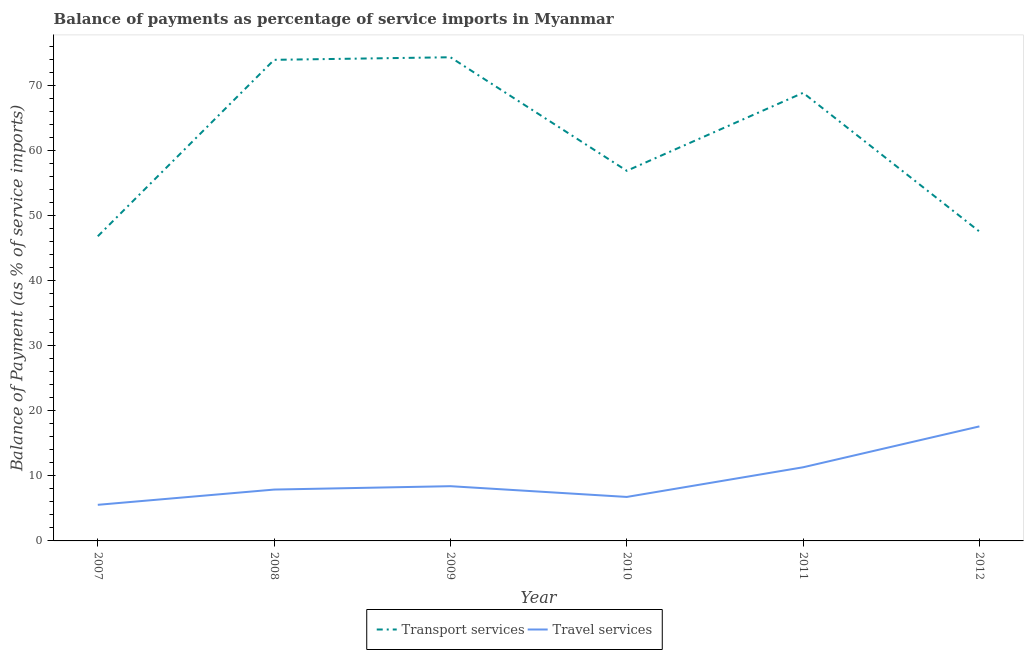How many different coloured lines are there?
Your answer should be compact. 2. Does the line corresponding to balance of payments of travel services intersect with the line corresponding to balance of payments of transport services?
Offer a very short reply. No. Is the number of lines equal to the number of legend labels?
Your response must be concise. Yes. What is the balance of payments of travel services in 2010?
Keep it short and to the point. 6.76. Across all years, what is the maximum balance of payments of travel services?
Offer a very short reply. 17.6. Across all years, what is the minimum balance of payments of travel services?
Your answer should be very brief. 5.55. What is the total balance of payments of transport services in the graph?
Give a very brief answer. 368.35. What is the difference between the balance of payments of transport services in 2009 and that in 2011?
Provide a succinct answer. 5.47. What is the difference between the balance of payments of transport services in 2012 and the balance of payments of travel services in 2009?
Give a very brief answer. 39.13. What is the average balance of payments of transport services per year?
Make the answer very short. 61.39. In the year 2009, what is the difference between the balance of payments of transport services and balance of payments of travel services?
Your answer should be very brief. 65.92. In how many years, is the balance of payments of transport services greater than 68 %?
Your answer should be very brief. 3. What is the ratio of the balance of payments of travel services in 2007 to that in 2011?
Your answer should be compact. 0.49. Is the difference between the balance of payments of transport services in 2007 and 2009 greater than the difference between the balance of payments of travel services in 2007 and 2009?
Offer a terse response. No. What is the difference between the highest and the second highest balance of payments of transport services?
Offer a terse response. 0.4. What is the difference between the highest and the lowest balance of payments of travel services?
Ensure brevity in your answer.  12.05. In how many years, is the balance of payments of travel services greater than the average balance of payments of travel services taken over all years?
Your response must be concise. 2. Is the sum of the balance of payments of transport services in 2007 and 2009 greater than the maximum balance of payments of travel services across all years?
Provide a succinct answer. Yes. Does the balance of payments of travel services monotonically increase over the years?
Offer a very short reply. No. Is the balance of payments of transport services strictly greater than the balance of payments of travel services over the years?
Keep it short and to the point. Yes. Is the balance of payments of transport services strictly less than the balance of payments of travel services over the years?
Ensure brevity in your answer.  No. How many lines are there?
Offer a very short reply. 2. Does the graph contain any zero values?
Your answer should be compact. No. Does the graph contain grids?
Make the answer very short. No. How many legend labels are there?
Your answer should be very brief. 2. What is the title of the graph?
Provide a short and direct response. Balance of payments as percentage of service imports in Myanmar. What is the label or title of the X-axis?
Make the answer very short. Year. What is the label or title of the Y-axis?
Your response must be concise. Balance of Payment (as % of service imports). What is the Balance of Payment (as % of service imports) in Transport services in 2007?
Ensure brevity in your answer.  46.82. What is the Balance of Payment (as % of service imports) of Travel services in 2007?
Your response must be concise. 5.55. What is the Balance of Payment (as % of service imports) of Transport services in 2008?
Your answer should be compact. 73.93. What is the Balance of Payment (as % of service imports) in Travel services in 2008?
Your answer should be compact. 7.89. What is the Balance of Payment (as % of service imports) in Transport services in 2009?
Offer a very short reply. 74.33. What is the Balance of Payment (as % of service imports) of Travel services in 2009?
Keep it short and to the point. 8.41. What is the Balance of Payment (as % of service imports) in Transport services in 2010?
Offer a terse response. 56.88. What is the Balance of Payment (as % of service imports) in Travel services in 2010?
Your answer should be compact. 6.76. What is the Balance of Payment (as % of service imports) of Transport services in 2011?
Provide a short and direct response. 68.86. What is the Balance of Payment (as % of service imports) in Travel services in 2011?
Provide a short and direct response. 11.32. What is the Balance of Payment (as % of service imports) of Transport services in 2012?
Keep it short and to the point. 47.55. What is the Balance of Payment (as % of service imports) of Travel services in 2012?
Keep it short and to the point. 17.6. Across all years, what is the maximum Balance of Payment (as % of service imports) in Transport services?
Your response must be concise. 74.33. Across all years, what is the maximum Balance of Payment (as % of service imports) of Travel services?
Offer a terse response. 17.6. Across all years, what is the minimum Balance of Payment (as % of service imports) in Transport services?
Keep it short and to the point. 46.82. Across all years, what is the minimum Balance of Payment (as % of service imports) of Travel services?
Your answer should be very brief. 5.55. What is the total Balance of Payment (as % of service imports) of Transport services in the graph?
Your response must be concise. 368.35. What is the total Balance of Payment (as % of service imports) in Travel services in the graph?
Your answer should be compact. 57.52. What is the difference between the Balance of Payment (as % of service imports) in Transport services in 2007 and that in 2008?
Ensure brevity in your answer.  -27.11. What is the difference between the Balance of Payment (as % of service imports) in Travel services in 2007 and that in 2008?
Offer a very short reply. -2.34. What is the difference between the Balance of Payment (as % of service imports) in Transport services in 2007 and that in 2009?
Give a very brief answer. -27.51. What is the difference between the Balance of Payment (as % of service imports) in Travel services in 2007 and that in 2009?
Ensure brevity in your answer.  -2.86. What is the difference between the Balance of Payment (as % of service imports) in Transport services in 2007 and that in 2010?
Make the answer very short. -10.06. What is the difference between the Balance of Payment (as % of service imports) of Travel services in 2007 and that in 2010?
Your answer should be compact. -1.21. What is the difference between the Balance of Payment (as % of service imports) of Transport services in 2007 and that in 2011?
Offer a very short reply. -22.04. What is the difference between the Balance of Payment (as % of service imports) of Travel services in 2007 and that in 2011?
Give a very brief answer. -5.77. What is the difference between the Balance of Payment (as % of service imports) in Transport services in 2007 and that in 2012?
Your response must be concise. -0.73. What is the difference between the Balance of Payment (as % of service imports) of Travel services in 2007 and that in 2012?
Give a very brief answer. -12.05. What is the difference between the Balance of Payment (as % of service imports) of Transport services in 2008 and that in 2009?
Offer a terse response. -0.4. What is the difference between the Balance of Payment (as % of service imports) in Travel services in 2008 and that in 2009?
Your answer should be compact. -0.52. What is the difference between the Balance of Payment (as % of service imports) in Transport services in 2008 and that in 2010?
Your answer should be compact. 17.05. What is the difference between the Balance of Payment (as % of service imports) of Travel services in 2008 and that in 2010?
Your answer should be very brief. 1.13. What is the difference between the Balance of Payment (as % of service imports) of Transport services in 2008 and that in 2011?
Provide a short and direct response. 5.07. What is the difference between the Balance of Payment (as % of service imports) of Travel services in 2008 and that in 2011?
Make the answer very short. -3.43. What is the difference between the Balance of Payment (as % of service imports) in Transport services in 2008 and that in 2012?
Keep it short and to the point. 26.39. What is the difference between the Balance of Payment (as % of service imports) in Travel services in 2008 and that in 2012?
Your answer should be very brief. -9.71. What is the difference between the Balance of Payment (as % of service imports) of Transport services in 2009 and that in 2010?
Offer a very short reply. 17.45. What is the difference between the Balance of Payment (as % of service imports) in Travel services in 2009 and that in 2010?
Keep it short and to the point. 1.65. What is the difference between the Balance of Payment (as % of service imports) in Transport services in 2009 and that in 2011?
Your answer should be very brief. 5.47. What is the difference between the Balance of Payment (as % of service imports) in Travel services in 2009 and that in 2011?
Your answer should be very brief. -2.91. What is the difference between the Balance of Payment (as % of service imports) in Transport services in 2009 and that in 2012?
Give a very brief answer. 26.78. What is the difference between the Balance of Payment (as % of service imports) in Travel services in 2009 and that in 2012?
Keep it short and to the point. -9.19. What is the difference between the Balance of Payment (as % of service imports) of Transport services in 2010 and that in 2011?
Provide a short and direct response. -11.98. What is the difference between the Balance of Payment (as % of service imports) of Travel services in 2010 and that in 2011?
Offer a terse response. -4.56. What is the difference between the Balance of Payment (as % of service imports) of Transport services in 2010 and that in 2012?
Keep it short and to the point. 9.33. What is the difference between the Balance of Payment (as % of service imports) in Travel services in 2010 and that in 2012?
Offer a terse response. -10.84. What is the difference between the Balance of Payment (as % of service imports) of Transport services in 2011 and that in 2012?
Your response must be concise. 21.31. What is the difference between the Balance of Payment (as % of service imports) of Travel services in 2011 and that in 2012?
Make the answer very short. -6.28. What is the difference between the Balance of Payment (as % of service imports) in Transport services in 2007 and the Balance of Payment (as % of service imports) in Travel services in 2008?
Your answer should be very brief. 38.93. What is the difference between the Balance of Payment (as % of service imports) of Transport services in 2007 and the Balance of Payment (as % of service imports) of Travel services in 2009?
Keep it short and to the point. 38.41. What is the difference between the Balance of Payment (as % of service imports) in Transport services in 2007 and the Balance of Payment (as % of service imports) in Travel services in 2010?
Provide a short and direct response. 40.06. What is the difference between the Balance of Payment (as % of service imports) in Transport services in 2007 and the Balance of Payment (as % of service imports) in Travel services in 2011?
Offer a terse response. 35.5. What is the difference between the Balance of Payment (as % of service imports) in Transport services in 2007 and the Balance of Payment (as % of service imports) in Travel services in 2012?
Your response must be concise. 29.22. What is the difference between the Balance of Payment (as % of service imports) of Transport services in 2008 and the Balance of Payment (as % of service imports) of Travel services in 2009?
Give a very brief answer. 65.52. What is the difference between the Balance of Payment (as % of service imports) of Transport services in 2008 and the Balance of Payment (as % of service imports) of Travel services in 2010?
Offer a terse response. 67.17. What is the difference between the Balance of Payment (as % of service imports) of Transport services in 2008 and the Balance of Payment (as % of service imports) of Travel services in 2011?
Keep it short and to the point. 62.61. What is the difference between the Balance of Payment (as % of service imports) of Transport services in 2008 and the Balance of Payment (as % of service imports) of Travel services in 2012?
Offer a very short reply. 56.33. What is the difference between the Balance of Payment (as % of service imports) of Transport services in 2009 and the Balance of Payment (as % of service imports) of Travel services in 2010?
Keep it short and to the point. 67.57. What is the difference between the Balance of Payment (as % of service imports) in Transport services in 2009 and the Balance of Payment (as % of service imports) in Travel services in 2011?
Your response must be concise. 63.01. What is the difference between the Balance of Payment (as % of service imports) of Transport services in 2009 and the Balance of Payment (as % of service imports) of Travel services in 2012?
Offer a very short reply. 56.73. What is the difference between the Balance of Payment (as % of service imports) in Transport services in 2010 and the Balance of Payment (as % of service imports) in Travel services in 2011?
Your answer should be compact. 45.56. What is the difference between the Balance of Payment (as % of service imports) of Transport services in 2010 and the Balance of Payment (as % of service imports) of Travel services in 2012?
Offer a terse response. 39.28. What is the difference between the Balance of Payment (as % of service imports) of Transport services in 2011 and the Balance of Payment (as % of service imports) of Travel services in 2012?
Your answer should be very brief. 51.26. What is the average Balance of Payment (as % of service imports) in Transport services per year?
Give a very brief answer. 61.39. What is the average Balance of Payment (as % of service imports) in Travel services per year?
Make the answer very short. 9.59. In the year 2007, what is the difference between the Balance of Payment (as % of service imports) of Transport services and Balance of Payment (as % of service imports) of Travel services?
Provide a short and direct response. 41.27. In the year 2008, what is the difference between the Balance of Payment (as % of service imports) of Transport services and Balance of Payment (as % of service imports) of Travel services?
Keep it short and to the point. 66.04. In the year 2009, what is the difference between the Balance of Payment (as % of service imports) of Transport services and Balance of Payment (as % of service imports) of Travel services?
Offer a terse response. 65.92. In the year 2010, what is the difference between the Balance of Payment (as % of service imports) in Transport services and Balance of Payment (as % of service imports) in Travel services?
Offer a terse response. 50.12. In the year 2011, what is the difference between the Balance of Payment (as % of service imports) of Transport services and Balance of Payment (as % of service imports) of Travel services?
Ensure brevity in your answer.  57.54. In the year 2012, what is the difference between the Balance of Payment (as % of service imports) in Transport services and Balance of Payment (as % of service imports) in Travel services?
Make the answer very short. 29.95. What is the ratio of the Balance of Payment (as % of service imports) in Transport services in 2007 to that in 2008?
Offer a very short reply. 0.63. What is the ratio of the Balance of Payment (as % of service imports) of Travel services in 2007 to that in 2008?
Give a very brief answer. 0.7. What is the ratio of the Balance of Payment (as % of service imports) in Transport services in 2007 to that in 2009?
Make the answer very short. 0.63. What is the ratio of the Balance of Payment (as % of service imports) of Travel services in 2007 to that in 2009?
Make the answer very short. 0.66. What is the ratio of the Balance of Payment (as % of service imports) in Transport services in 2007 to that in 2010?
Offer a very short reply. 0.82. What is the ratio of the Balance of Payment (as % of service imports) of Travel services in 2007 to that in 2010?
Ensure brevity in your answer.  0.82. What is the ratio of the Balance of Payment (as % of service imports) in Transport services in 2007 to that in 2011?
Make the answer very short. 0.68. What is the ratio of the Balance of Payment (as % of service imports) of Travel services in 2007 to that in 2011?
Your answer should be compact. 0.49. What is the ratio of the Balance of Payment (as % of service imports) in Transport services in 2007 to that in 2012?
Your answer should be very brief. 0.98. What is the ratio of the Balance of Payment (as % of service imports) in Travel services in 2007 to that in 2012?
Ensure brevity in your answer.  0.32. What is the ratio of the Balance of Payment (as % of service imports) of Transport services in 2008 to that in 2009?
Your answer should be compact. 0.99. What is the ratio of the Balance of Payment (as % of service imports) of Travel services in 2008 to that in 2009?
Offer a very short reply. 0.94. What is the ratio of the Balance of Payment (as % of service imports) in Transport services in 2008 to that in 2010?
Your response must be concise. 1.3. What is the ratio of the Balance of Payment (as % of service imports) of Travel services in 2008 to that in 2010?
Offer a very short reply. 1.17. What is the ratio of the Balance of Payment (as % of service imports) in Transport services in 2008 to that in 2011?
Offer a very short reply. 1.07. What is the ratio of the Balance of Payment (as % of service imports) of Travel services in 2008 to that in 2011?
Ensure brevity in your answer.  0.7. What is the ratio of the Balance of Payment (as % of service imports) in Transport services in 2008 to that in 2012?
Give a very brief answer. 1.55. What is the ratio of the Balance of Payment (as % of service imports) of Travel services in 2008 to that in 2012?
Make the answer very short. 0.45. What is the ratio of the Balance of Payment (as % of service imports) of Transport services in 2009 to that in 2010?
Keep it short and to the point. 1.31. What is the ratio of the Balance of Payment (as % of service imports) of Travel services in 2009 to that in 2010?
Keep it short and to the point. 1.24. What is the ratio of the Balance of Payment (as % of service imports) of Transport services in 2009 to that in 2011?
Ensure brevity in your answer.  1.08. What is the ratio of the Balance of Payment (as % of service imports) of Travel services in 2009 to that in 2011?
Your response must be concise. 0.74. What is the ratio of the Balance of Payment (as % of service imports) in Transport services in 2009 to that in 2012?
Offer a very short reply. 1.56. What is the ratio of the Balance of Payment (as % of service imports) in Travel services in 2009 to that in 2012?
Give a very brief answer. 0.48. What is the ratio of the Balance of Payment (as % of service imports) in Transport services in 2010 to that in 2011?
Ensure brevity in your answer.  0.83. What is the ratio of the Balance of Payment (as % of service imports) in Travel services in 2010 to that in 2011?
Your answer should be compact. 0.6. What is the ratio of the Balance of Payment (as % of service imports) of Transport services in 2010 to that in 2012?
Make the answer very short. 1.2. What is the ratio of the Balance of Payment (as % of service imports) of Travel services in 2010 to that in 2012?
Your response must be concise. 0.38. What is the ratio of the Balance of Payment (as % of service imports) of Transport services in 2011 to that in 2012?
Ensure brevity in your answer.  1.45. What is the ratio of the Balance of Payment (as % of service imports) in Travel services in 2011 to that in 2012?
Give a very brief answer. 0.64. What is the difference between the highest and the second highest Balance of Payment (as % of service imports) in Transport services?
Ensure brevity in your answer.  0.4. What is the difference between the highest and the second highest Balance of Payment (as % of service imports) of Travel services?
Give a very brief answer. 6.28. What is the difference between the highest and the lowest Balance of Payment (as % of service imports) of Transport services?
Make the answer very short. 27.51. What is the difference between the highest and the lowest Balance of Payment (as % of service imports) in Travel services?
Your answer should be very brief. 12.05. 